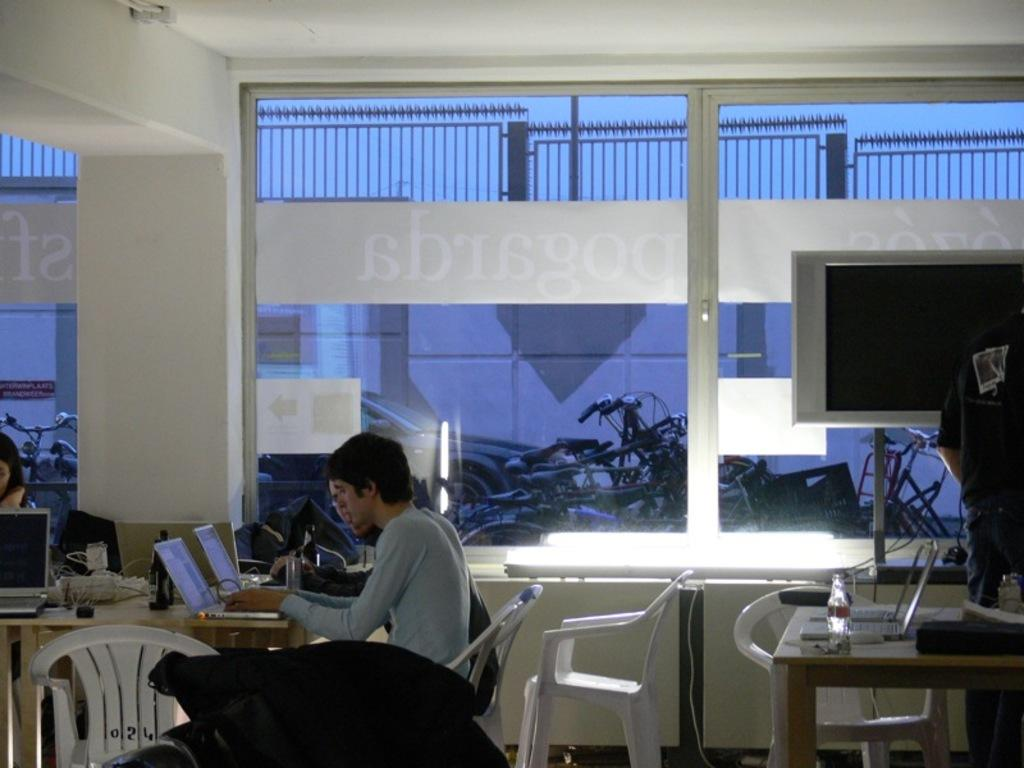How many persons are in the image? There are two persons in the image. What are the persons doing in the image? The persons are sitting near a table and operating a laptop. Can you describe the furniture in the image? There is a chair in the image. What type of electronic devices can be seen in the image? There is a laptop, a television, and a bottle in the image. What is visible in the background of the image? There is a building in the background of the image. Are there any vehicles present in the image? Yes, there is a bicycle and a car in the image. What type of insect is crawling on the laptop in the image? There are no insects present in the image; the persons are operating the laptop without any visible insects. 